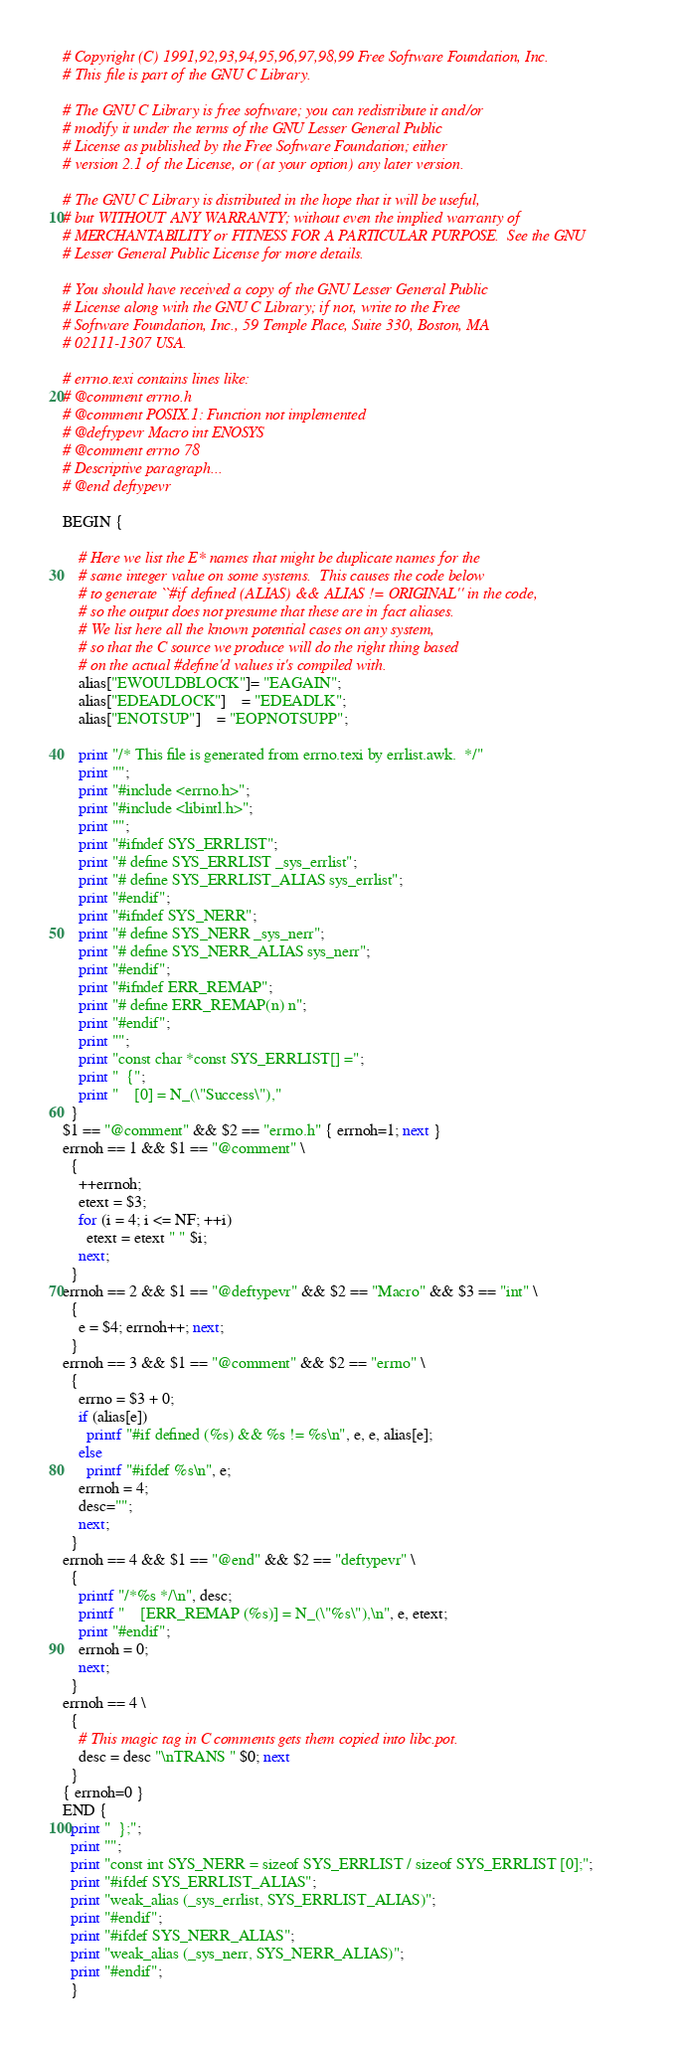<code> <loc_0><loc_0><loc_500><loc_500><_Awk_># Copyright (C) 1991,92,93,94,95,96,97,98,99 Free Software Foundation, Inc.
# This file is part of the GNU C Library.

# The GNU C Library is free software; you can redistribute it and/or
# modify it under the terms of the GNU Lesser General Public
# License as published by the Free Software Foundation; either
# version 2.1 of the License, or (at your option) any later version.

# The GNU C Library is distributed in the hope that it will be useful,
# but WITHOUT ANY WARRANTY; without even the implied warranty of
# MERCHANTABILITY or FITNESS FOR A PARTICULAR PURPOSE.  See the GNU
# Lesser General Public License for more details.

# You should have received a copy of the GNU Lesser General Public
# License along with the GNU C Library; if not, write to the Free
# Software Foundation, Inc., 59 Temple Place, Suite 330, Boston, MA
# 02111-1307 USA.

# errno.texi contains lines like:
# @comment errno.h
# @comment POSIX.1: Function not implemented
# @deftypevr Macro int ENOSYS
# @comment errno 78
# Descriptive paragraph...
# @end deftypevr

BEGIN {

    # Here we list the E* names that might be duplicate names for the
    # same integer value on some systems.  This causes the code below
    # to generate ``#if defined (ALIAS) && ALIAS != ORIGINAL'' in the code,
    # so the output does not presume that these are in fact aliases.
    # We list here all the known potential cases on any system,
    # so that the C source we produce will do the right thing based
    # on the actual #define'd values it's compiled with.
    alias["EWOULDBLOCK"]= "EAGAIN";
    alias["EDEADLOCK"]	= "EDEADLK";
    alias["ENOTSUP"]	= "EOPNOTSUPP";

    print "/* This file is generated from errno.texi by errlist.awk.  */"
    print "";
    print "#include <errno.h>";
    print "#include <libintl.h>";
    print "";
    print "#ifndef SYS_ERRLIST";
    print "# define SYS_ERRLIST _sys_errlist";
    print "# define SYS_ERRLIST_ALIAS sys_errlist";
    print "#endif";
    print "#ifndef SYS_NERR";
    print "# define SYS_NERR _sys_nerr";
    print "# define SYS_NERR_ALIAS sys_nerr";
    print "#endif";
    print "#ifndef ERR_REMAP";
    print "# define ERR_REMAP(n) n";
    print "#endif";
    print "";
    print "const char *const SYS_ERRLIST[] =";
    print "  {";
    print "    [0] = N_(\"Success\"),"
  }
$1 == "@comment" && $2 == "errno.h" { errnoh=1; next }
errnoh == 1 && $1 == "@comment" \
  {
    ++errnoh;
    etext = $3;
    for (i = 4; i <= NF; ++i)
      etext = etext " " $i;
    next;
  }
errnoh == 2 && $1 == "@deftypevr" && $2 == "Macro" && $3 == "int" \
  {
    e = $4; errnoh++; next;
  }
errnoh == 3 && $1 == "@comment" && $2 == "errno" \
  {
    errno = $3 + 0;
    if (alias[e])
      printf "#if defined (%s) && %s != %s\n", e, e, alias[e];
    else
      printf "#ifdef %s\n", e;
    errnoh = 4;
    desc="";
    next;
  }
errnoh == 4 && $1 == "@end" && $2 == "deftypevr" \
  {
    printf "/*%s */\n", desc;
    printf "    [ERR_REMAP (%s)] = N_(\"%s\"),\n", e, etext;
    print "#endif";
    errnoh = 0;
    next;
  }
errnoh == 4 \
  {
    # This magic tag in C comments gets them copied into libc.pot.
    desc = desc "\nTRANS " $0; next
  }
{ errnoh=0 }
END {
  print "  };";
  print "";
  print "const int SYS_NERR = sizeof SYS_ERRLIST / sizeof SYS_ERRLIST [0];";
  print "#ifdef SYS_ERRLIST_ALIAS";
  print "weak_alias (_sys_errlist, SYS_ERRLIST_ALIAS)";
  print "#endif";
  print "#ifdef SYS_NERR_ALIAS";
  print "weak_alias (_sys_nerr, SYS_NERR_ALIAS)";
  print "#endif";
  }
</code> 